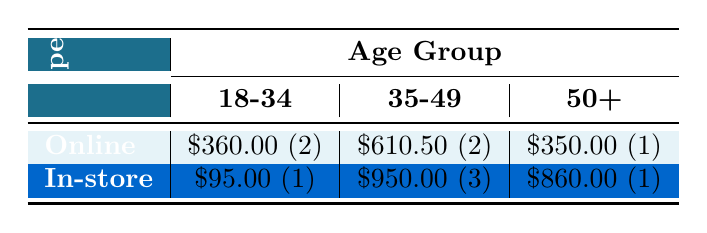What is the total amount spent by Seattle residents on online purchases in the age group 18-34? In the table, the total spent on online purchases for the age group 18-34 is \$360.00 (from 2 purchases).
Answer: 360.00 How much did Seattle residents aged 35-49 spend in total on in-store purchases? The table shows that residents aged 35-49 spent \$950.00 across 3 in-store purchases.
Answer: 950.00 Is it true that the total expenditure for online purchases is greater than that for in-store purchases in the age group 50+? The total for online purchases in the age group 50+ is \$350.00 and for in-store purchases it is \$860.00. Since 350.00 is less than 860.00, the statement is false.
Answer: No What is the average spend on online purchases for the age group 35-49? For the age group 35-49, there are two online purchases totaling \$610.50. To find the average, divide 610.50 by 2, which equals \$305.25.
Answer: 305.25 Which purchase type had a higher total, online or in-store, when considering the age group 50+? The total for online purchases in the age group 50+ is \$350.00, whereas for in-store purchases it totals \$860.00. Since 860.00 is greater than 350.00, in-store purchases had a higher total.
Answer: In-store How many distinct age groups made online purchases? Analyzing the table, online purchases were made by two distinct age groups: 18-34 and 35-49. Thus, there are two age groups for online purchases.
Answer: 2 What is the difference between the total amount spent by the 35-49 age group on in-store purchases compared to the 50+ age group? The total expenditure for the 35-49 age group on in-store purchases is \$950.00, while for the 50+ age group, it is \$860.00. The difference is 950.00 - 860.00 = 90.00.
Answer: 90.00 Did more people make in-store purchases than online purchases in the age group 18-34? The table shows that there are 2 online purchases (totaling \$360.00) and 1 in-store purchase (totaling \$95.00) in the age group 18-34, indicating more online purchases.
Answer: No 